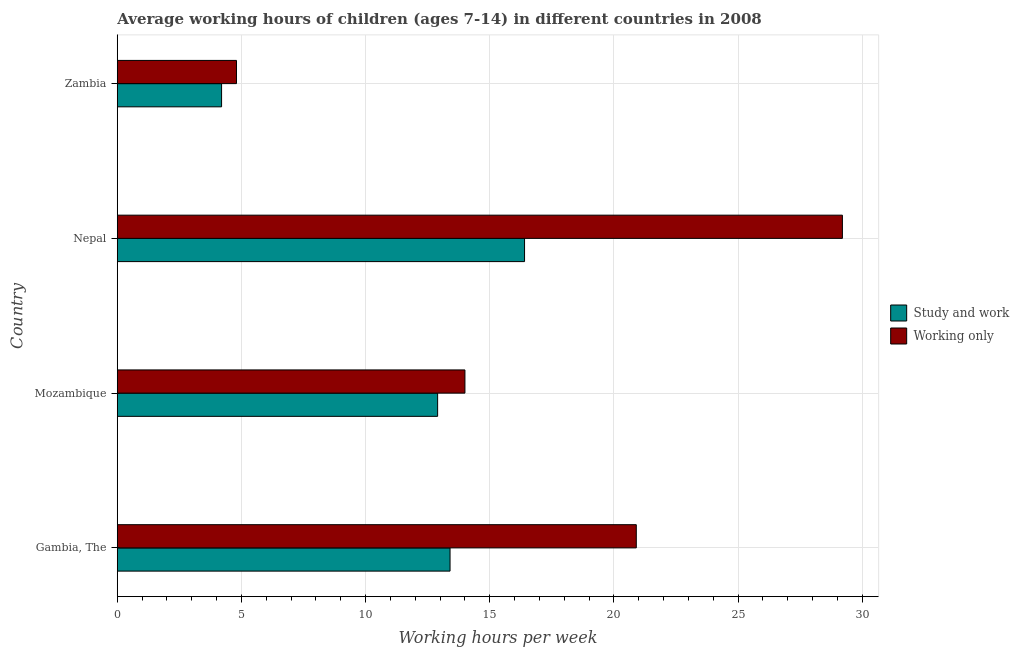How many groups of bars are there?
Your answer should be very brief. 4. Are the number of bars on each tick of the Y-axis equal?
Your response must be concise. Yes. How many bars are there on the 1st tick from the top?
Provide a short and direct response. 2. What is the label of the 4th group of bars from the top?
Your response must be concise. Gambia, The. In how many cases, is the number of bars for a given country not equal to the number of legend labels?
Provide a succinct answer. 0. What is the average working hour of children involved in study and work in Mozambique?
Offer a very short reply. 12.9. Across all countries, what is the maximum average working hour of children involved in only work?
Make the answer very short. 29.2. In which country was the average working hour of children involved in only work maximum?
Offer a terse response. Nepal. In which country was the average working hour of children involved in only work minimum?
Give a very brief answer. Zambia. What is the total average working hour of children involved in study and work in the graph?
Your answer should be very brief. 46.9. What is the difference between the average working hour of children involved in study and work in Gambia, The and that in Mozambique?
Give a very brief answer. 0.5. What is the difference between the average working hour of children involved in study and work in Mozambique and the average working hour of children involved in only work in Nepal?
Offer a terse response. -16.3. What is the average average working hour of children involved in only work per country?
Give a very brief answer. 17.23. In how many countries, is the average working hour of children involved in only work greater than 16 hours?
Offer a terse response. 2. What is the ratio of the average working hour of children involved in study and work in Mozambique to that in Nepal?
Give a very brief answer. 0.79. Is the average working hour of children involved in only work in Nepal less than that in Zambia?
Provide a succinct answer. No. Is the difference between the average working hour of children involved in only work in Mozambique and Nepal greater than the difference between the average working hour of children involved in study and work in Mozambique and Nepal?
Give a very brief answer. No. Is the sum of the average working hour of children involved in only work in Nepal and Zambia greater than the maximum average working hour of children involved in study and work across all countries?
Keep it short and to the point. Yes. What does the 1st bar from the top in Zambia represents?
Offer a very short reply. Working only. What does the 2nd bar from the bottom in Nepal represents?
Offer a very short reply. Working only. How many countries are there in the graph?
Offer a terse response. 4. What is the difference between two consecutive major ticks on the X-axis?
Make the answer very short. 5. Does the graph contain grids?
Give a very brief answer. Yes. What is the title of the graph?
Offer a terse response. Average working hours of children (ages 7-14) in different countries in 2008. Does "Private creditors" appear as one of the legend labels in the graph?
Your answer should be compact. No. What is the label or title of the X-axis?
Make the answer very short. Working hours per week. What is the Working hours per week in Study and work in Gambia, The?
Your answer should be very brief. 13.4. What is the Working hours per week of Working only in Gambia, The?
Your answer should be very brief. 20.9. What is the Working hours per week of Study and work in Mozambique?
Your response must be concise. 12.9. What is the Working hours per week in Working only in Mozambique?
Give a very brief answer. 14. What is the Working hours per week of Working only in Nepal?
Your response must be concise. 29.2. What is the Working hours per week in Study and work in Zambia?
Your response must be concise. 4.2. What is the Working hours per week of Working only in Zambia?
Your answer should be very brief. 4.8. Across all countries, what is the maximum Working hours per week of Study and work?
Your answer should be very brief. 16.4. Across all countries, what is the maximum Working hours per week of Working only?
Ensure brevity in your answer.  29.2. Across all countries, what is the minimum Working hours per week in Working only?
Your answer should be compact. 4.8. What is the total Working hours per week in Study and work in the graph?
Offer a terse response. 46.9. What is the total Working hours per week of Working only in the graph?
Offer a terse response. 68.9. What is the difference between the Working hours per week in Working only in Gambia, The and that in Mozambique?
Provide a short and direct response. 6.9. What is the difference between the Working hours per week in Study and work in Gambia, The and that in Nepal?
Offer a very short reply. -3. What is the difference between the Working hours per week in Working only in Gambia, The and that in Nepal?
Offer a terse response. -8.3. What is the difference between the Working hours per week of Study and work in Mozambique and that in Nepal?
Ensure brevity in your answer.  -3.5. What is the difference between the Working hours per week in Working only in Mozambique and that in Nepal?
Give a very brief answer. -15.2. What is the difference between the Working hours per week of Study and work in Mozambique and that in Zambia?
Make the answer very short. 8.7. What is the difference between the Working hours per week of Study and work in Nepal and that in Zambia?
Give a very brief answer. 12.2. What is the difference between the Working hours per week in Working only in Nepal and that in Zambia?
Offer a terse response. 24.4. What is the difference between the Working hours per week in Study and work in Gambia, The and the Working hours per week in Working only in Mozambique?
Make the answer very short. -0.6. What is the difference between the Working hours per week of Study and work in Gambia, The and the Working hours per week of Working only in Nepal?
Your answer should be very brief. -15.8. What is the difference between the Working hours per week of Study and work in Mozambique and the Working hours per week of Working only in Nepal?
Your response must be concise. -16.3. What is the difference between the Working hours per week in Study and work in Mozambique and the Working hours per week in Working only in Zambia?
Ensure brevity in your answer.  8.1. What is the difference between the Working hours per week of Study and work in Nepal and the Working hours per week of Working only in Zambia?
Ensure brevity in your answer.  11.6. What is the average Working hours per week in Study and work per country?
Ensure brevity in your answer.  11.72. What is the average Working hours per week of Working only per country?
Give a very brief answer. 17.23. What is the difference between the Working hours per week in Study and work and Working hours per week in Working only in Mozambique?
Give a very brief answer. -1.1. What is the difference between the Working hours per week in Study and work and Working hours per week in Working only in Nepal?
Your response must be concise. -12.8. What is the ratio of the Working hours per week in Study and work in Gambia, The to that in Mozambique?
Your response must be concise. 1.04. What is the ratio of the Working hours per week of Working only in Gambia, The to that in Mozambique?
Ensure brevity in your answer.  1.49. What is the ratio of the Working hours per week in Study and work in Gambia, The to that in Nepal?
Provide a short and direct response. 0.82. What is the ratio of the Working hours per week in Working only in Gambia, The to that in Nepal?
Make the answer very short. 0.72. What is the ratio of the Working hours per week of Study and work in Gambia, The to that in Zambia?
Offer a very short reply. 3.19. What is the ratio of the Working hours per week in Working only in Gambia, The to that in Zambia?
Your answer should be compact. 4.35. What is the ratio of the Working hours per week in Study and work in Mozambique to that in Nepal?
Make the answer very short. 0.79. What is the ratio of the Working hours per week of Working only in Mozambique to that in Nepal?
Your answer should be compact. 0.48. What is the ratio of the Working hours per week of Study and work in Mozambique to that in Zambia?
Keep it short and to the point. 3.07. What is the ratio of the Working hours per week in Working only in Mozambique to that in Zambia?
Provide a succinct answer. 2.92. What is the ratio of the Working hours per week of Study and work in Nepal to that in Zambia?
Keep it short and to the point. 3.9. What is the ratio of the Working hours per week of Working only in Nepal to that in Zambia?
Provide a short and direct response. 6.08. What is the difference between the highest and the second highest Working hours per week in Working only?
Your answer should be compact. 8.3. What is the difference between the highest and the lowest Working hours per week of Working only?
Ensure brevity in your answer.  24.4. 